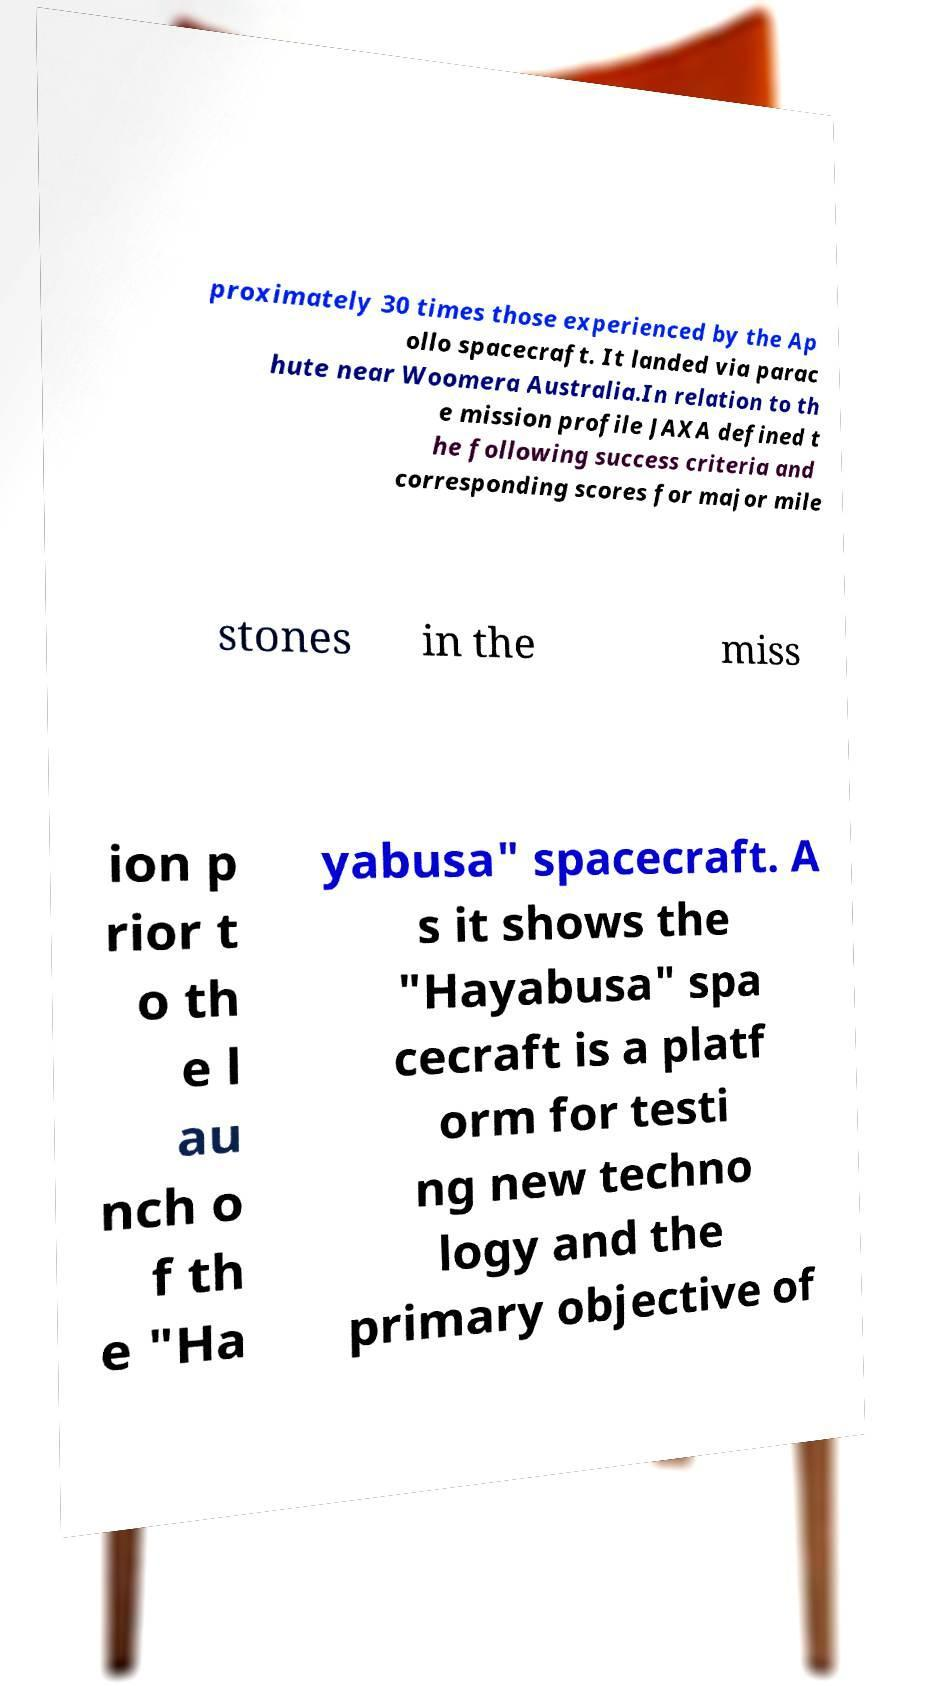Please read and relay the text visible in this image. What does it say? proximately 30 times those experienced by the Ap ollo spacecraft. It landed via parac hute near Woomera Australia.In relation to th e mission profile JAXA defined t he following success criteria and corresponding scores for major mile stones in the miss ion p rior t o th e l au nch o f th e "Ha yabusa" spacecraft. A s it shows the "Hayabusa" spa cecraft is a platf orm for testi ng new techno logy and the primary objective of 